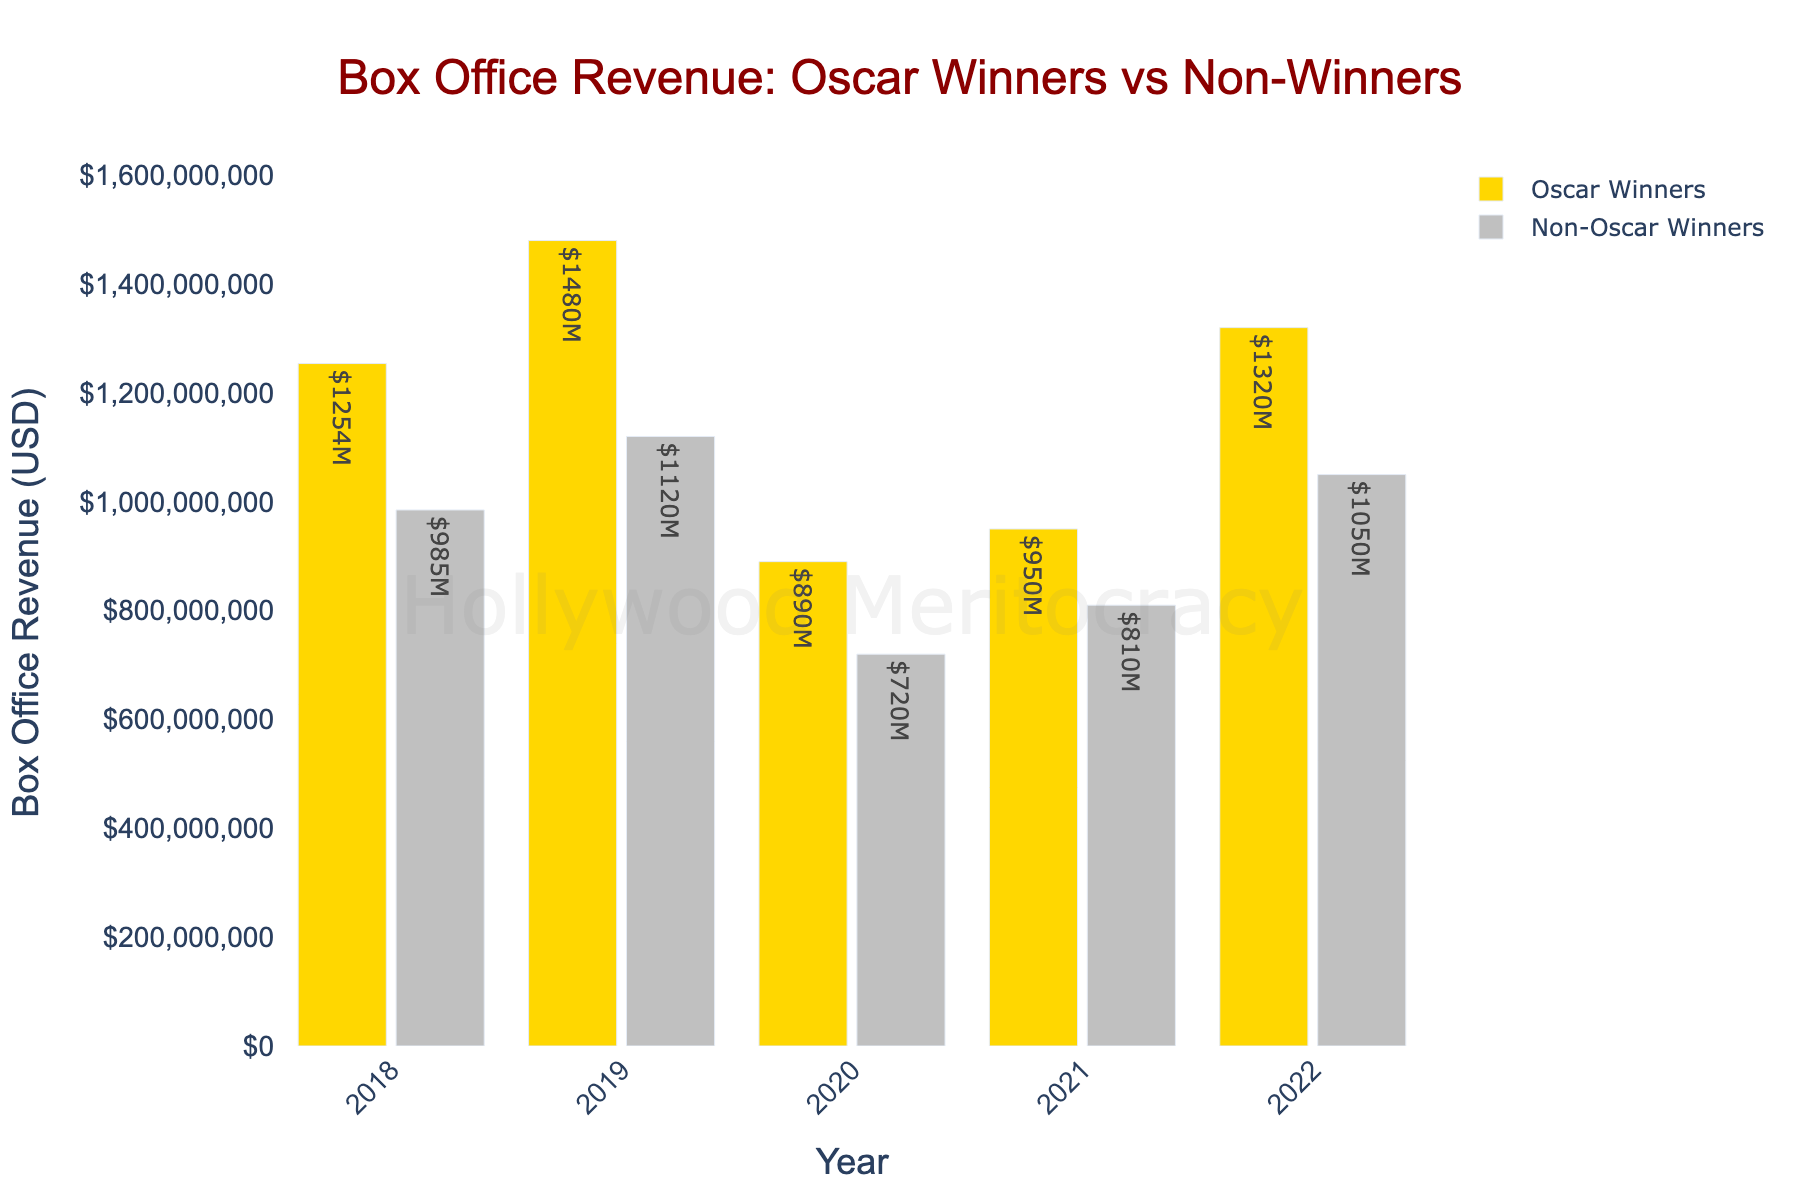What's the difference in box office revenue between Oscar winners and non-winners in 2019? To find the difference, subtract the revenue of non-winners from the revenue of winners: 1,480,000,000 - 1,120,000,000 = 360,000,000
Answer: 360,000,000 Which year had the smallest difference in box office revenue between Oscar winners and non-winners? Calculate the difference for each year: 2018 (269,000,000), 2019 (360,000,000), 2020 (170,000,000), 2021 (140,000,000), 2022 (270,000,000). The smallest difference is in 2021 with 140,000,000
Answer: 2021 How much more revenue did Oscar winners have compared to non-winners in 2022? Subtract the revenue of non-winners from the revenue of winners in 2022: 1,320,000,000 - 1,050,000,000 = 270,000,000
Answer: 270,000,000 In which years did Oscar winners have over 1,000,000,000 in revenue? Identify the years where the revenue of Oscar winners is greater than 1,000,000,000: 2018 (1,254,000,000), 2019 (1,480,000,000), and 2022 (1,320,000,000)
Answer: 2018, 2019, 2022 Which group had higher revenue in 2020? Compare the revenue of both groups in 2020: Oscar winners (890,000,000) vs. Non-Oscar winners (720,000,000). Oscar winners had higher revenue
Answer: Oscar winners What is the average box office revenue for non-Oscar winners from 2018 to 2022? Sum the revenues for non-winners and then divide by 5: (985,000,000 + 1,120,000,000 + 720,000,000 + 810,000,000 + 1,050,000,000) / 5 = 937,000,000
Answer: 937,000,000 Which year shows the highest revenue for non-Oscar winners? Check the revenues for non-Oscar winners across all years: 2018 (985,000,000), 2019 (1,120,000,000), 2020 (720,000,000), 2021 (810,000,000), 2022 (1,050,000,000). The highest revenue is in 2019 with 1,120,000,000
Answer: 2019 What is the total box office revenue for Oscar winners from 2018 to 2022? Sum the revenues for Oscar winners: 1,254,000,000 + 1,480,000,000 + 890,000,000 + 950,000,000 + 1,320,000,000 = 5,894,000,000
Answer: 5,894,000,000 Which year had the closest box office revenue between Oscar winners and non-winners? Calculate the differences for each year: 2018 (269,000,000), 2019 (360,000,000), 2020 (170,000,000), 2021 (140,000,000), 2022 (270,000,000). The smallest difference is in 2021 with 140,000,000
Answer: 2021 